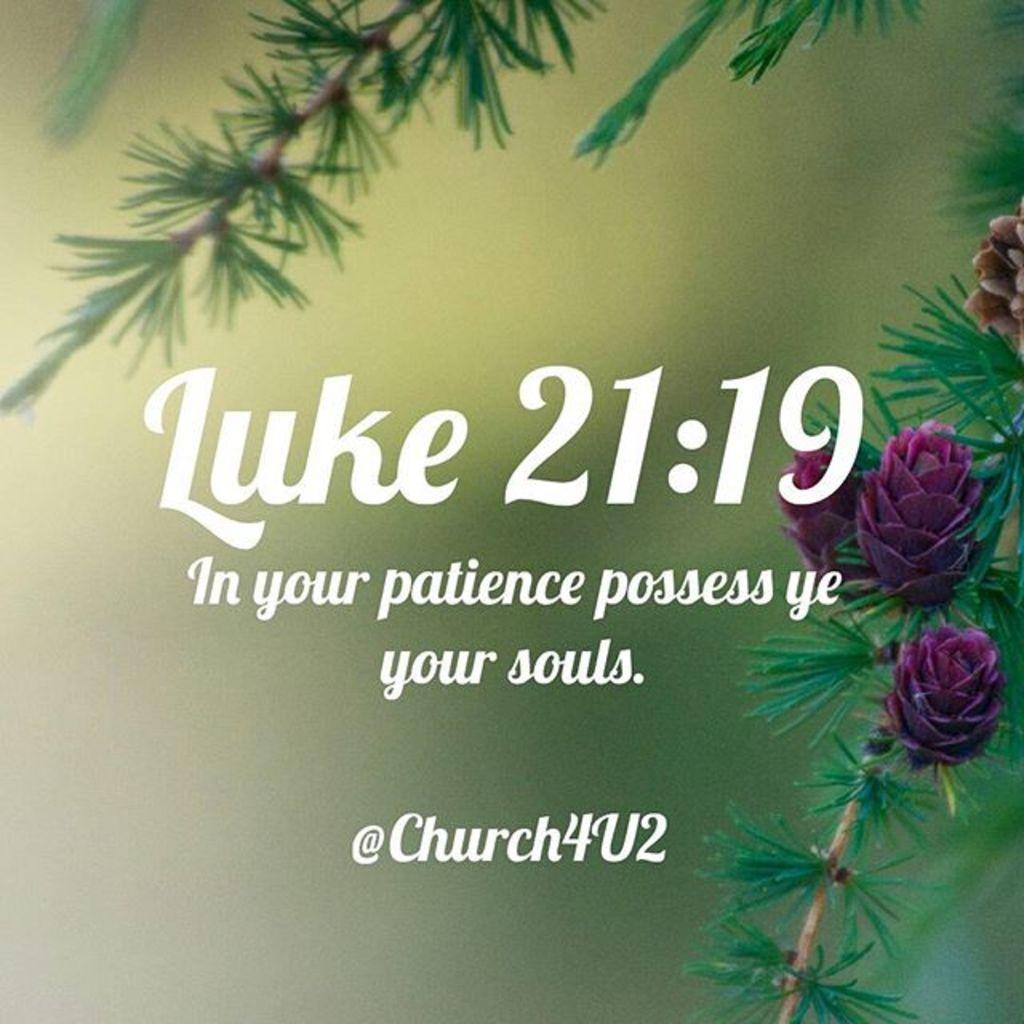What type of visual is the image? The image is a poster. What color are the texts on the poster? The texts on the poster are white. What type of floral elements are present in the image? There are pink colored flowers in the image. What other natural elements can be seen in the image? There are green color leaves of a tree in the image. How would you describe the background of the image? The background of the image is blurred. How many grapes are hanging from the tree in the image? There are no grapes present in the image; it features pink flowers and green leaves. What type of stationery item can be seen in the image? There is no stationery item, such as a pencil, present in the image. 